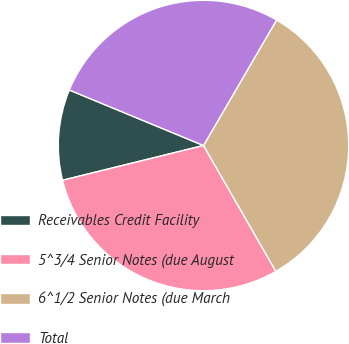<chart> <loc_0><loc_0><loc_500><loc_500><pie_chart><fcel>Receivables Credit Facility<fcel>5^3/4 Senior Notes (due August<fcel>6^1/2 Senior Notes (due March<fcel>Total<nl><fcel>10.09%<fcel>29.46%<fcel>33.3%<fcel>27.15%<nl></chart> 